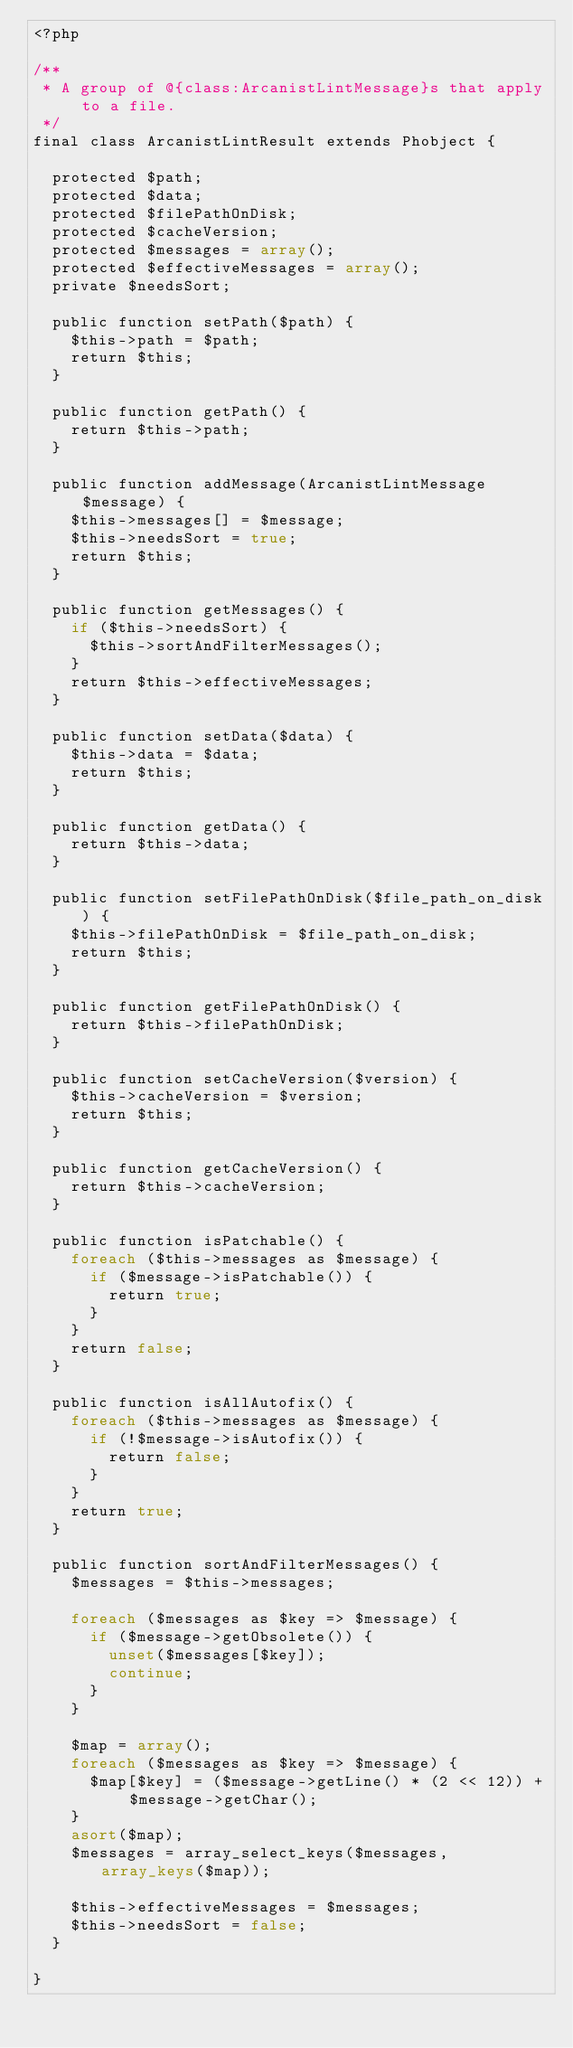<code> <loc_0><loc_0><loc_500><loc_500><_PHP_><?php

/**
 * A group of @{class:ArcanistLintMessage}s that apply to a file.
 */
final class ArcanistLintResult extends Phobject {

  protected $path;
  protected $data;
  protected $filePathOnDisk;
  protected $cacheVersion;
  protected $messages = array();
  protected $effectiveMessages = array();
  private $needsSort;

  public function setPath($path) {
    $this->path = $path;
    return $this;
  }

  public function getPath() {
    return $this->path;
  }

  public function addMessage(ArcanistLintMessage $message) {
    $this->messages[] = $message;
    $this->needsSort = true;
    return $this;
  }

  public function getMessages() {
    if ($this->needsSort) {
      $this->sortAndFilterMessages();
    }
    return $this->effectiveMessages;
  }

  public function setData($data) {
    $this->data = $data;
    return $this;
  }

  public function getData() {
    return $this->data;
  }

  public function setFilePathOnDisk($file_path_on_disk) {
    $this->filePathOnDisk = $file_path_on_disk;
    return $this;
  }

  public function getFilePathOnDisk() {
    return $this->filePathOnDisk;
  }

  public function setCacheVersion($version) {
    $this->cacheVersion = $version;
    return $this;
  }

  public function getCacheVersion() {
    return $this->cacheVersion;
  }

  public function isPatchable() {
    foreach ($this->messages as $message) {
      if ($message->isPatchable()) {
        return true;
      }
    }
    return false;
  }

  public function isAllAutofix() {
    foreach ($this->messages as $message) {
      if (!$message->isAutofix()) {
        return false;
      }
    }
    return true;
  }

  public function sortAndFilterMessages() {
    $messages = $this->messages;

    foreach ($messages as $key => $message) {
      if ($message->getObsolete()) {
        unset($messages[$key]);
        continue;
      }
    }

    $map = array();
    foreach ($messages as $key => $message) {
      $map[$key] = ($message->getLine() * (2 << 12)) + $message->getChar();
    }
    asort($map);
    $messages = array_select_keys($messages, array_keys($map));

    $this->effectiveMessages = $messages;
    $this->needsSort = false;
  }

}
</code> 